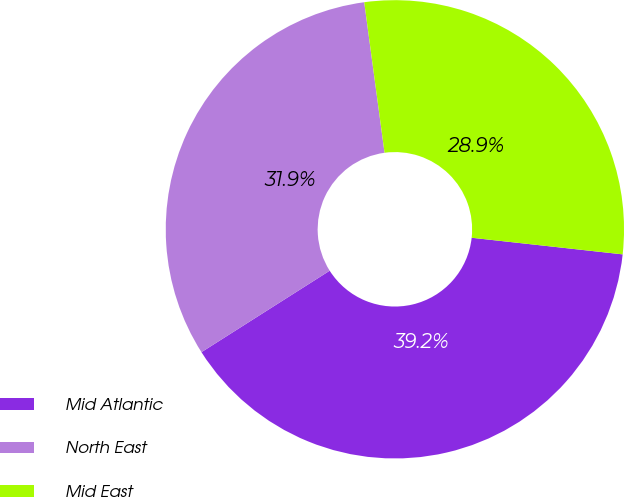Convert chart to OTSL. <chart><loc_0><loc_0><loc_500><loc_500><pie_chart><fcel>Mid Atlantic<fcel>North East<fcel>Mid East<nl><fcel>39.25%<fcel>31.87%<fcel>28.88%<nl></chart> 